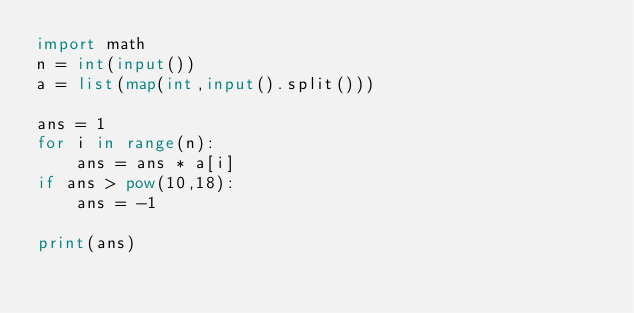Convert code to text. <code><loc_0><loc_0><loc_500><loc_500><_Python_>import math
n = int(input())
a = list(map(int,input().split()))

ans = 1
for i in range(n):
    ans = ans * a[i]
if ans > pow(10,18):
    ans = -1

print(ans)</code> 